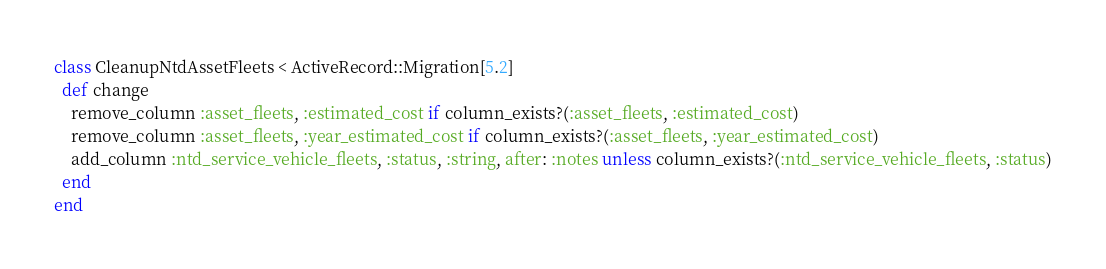Convert code to text. <code><loc_0><loc_0><loc_500><loc_500><_Ruby_>class CleanupNtdAssetFleets < ActiveRecord::Migration[5.2]
  def change
    remove_column :asset_fleets, :estimated_cost if column_exists?(:asset_fleets, :estimated_cost)
    remove_column :asset_fleets, :year_estimated_cost if column_exists?(:asset_fleets, :year_estimated_cost)
    add_column :ntd_service_vehicle_fleets, :status, :string, after: :notes unless column_exists?(:ntd_service_vehicle_fleets, :status)
  end
end</code> 